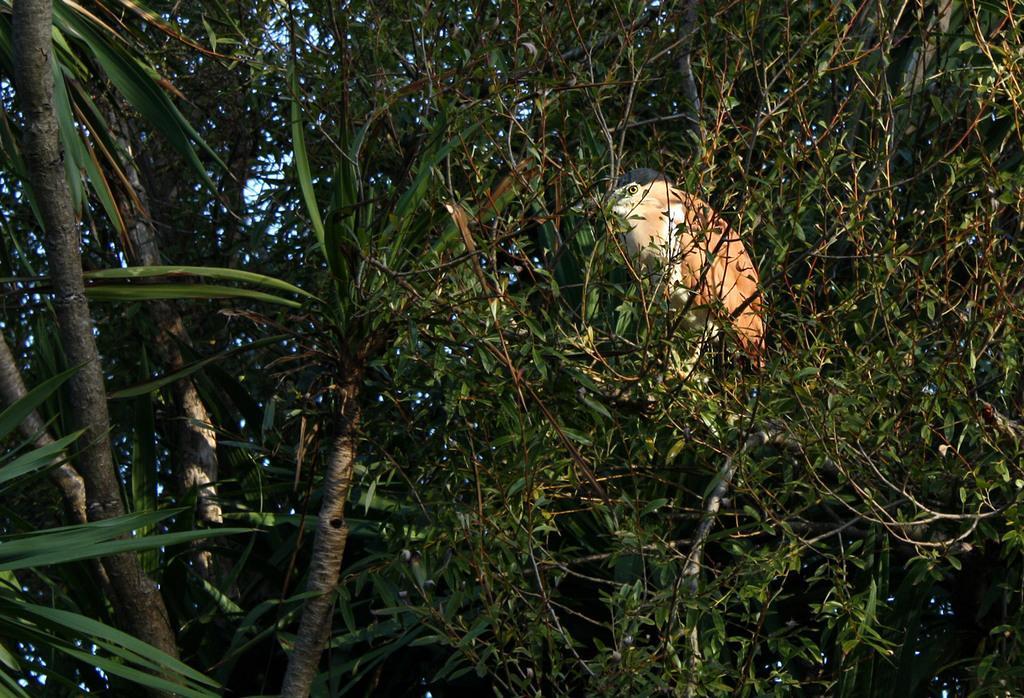Please provide a concise description of this image. In this image there are trees, on one tree there is a bird. 